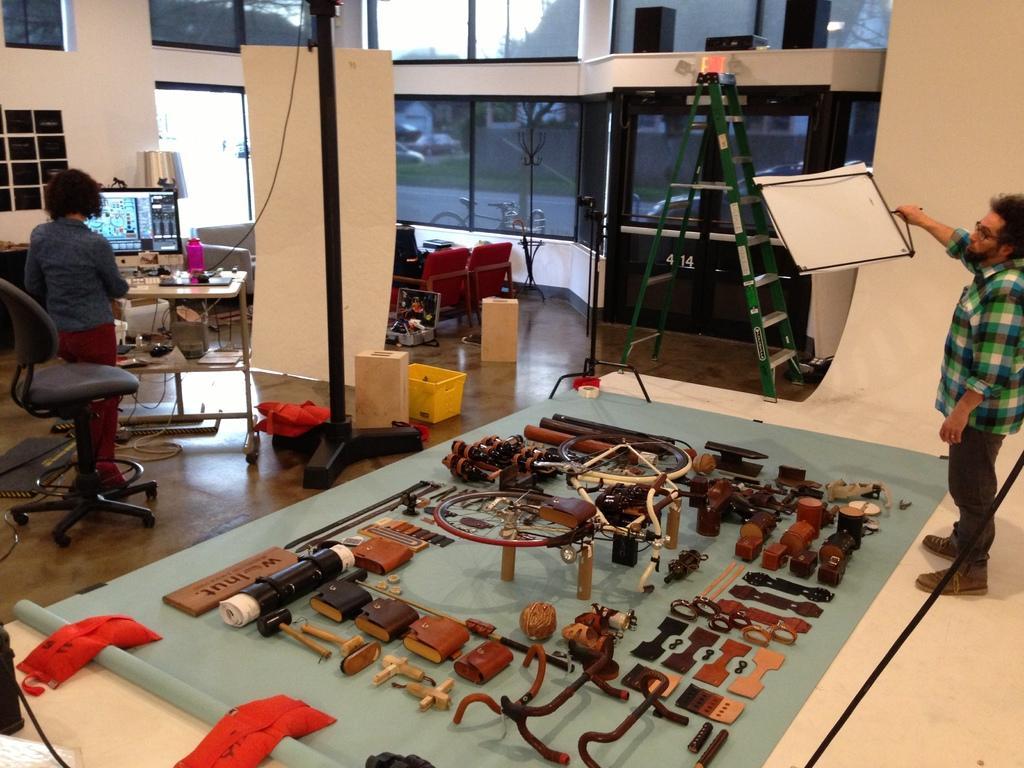Describe this image in one or two sentences. In the image in the center we can see some tools,and on the right side we can see one man standing. And in the center we can see the ladder. And on the left side we can see one woman standing. And on the back we can see wall,glass,monitor and some objects around them. 